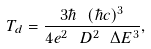<formula> <loc_0><loc_0><loc_500><loc_500>T _ { d } = \frac { 3 \hbar { \ } ( \hbar { c } ) ^ { 3 } } { 4 e ^ { 2 } \ D ^ { 2 } \ \Delta E ^ { 3 } } ,</formula> 